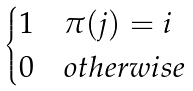<formula> <loc_0><loc_0><loc_500><loc_500>\begin{cases} 1 & \pi ( j ) = i \\ 0 & o t h e r w i s e \end{cases}</formula> 